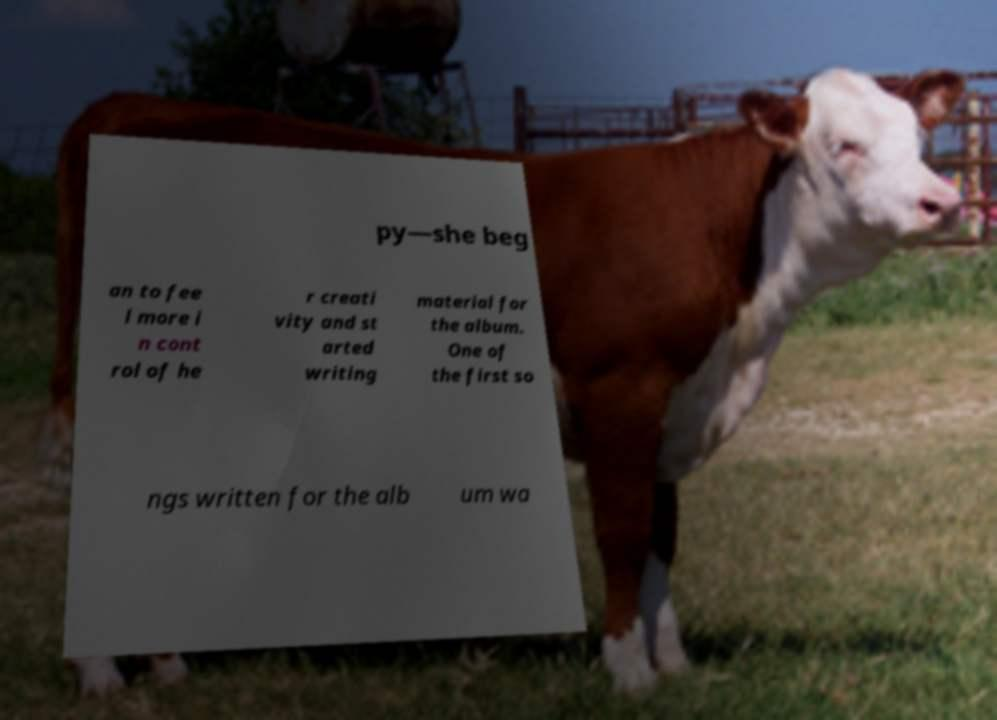Please read and relay the text visible in this image. What does it say? py—she beg an to fee l more i n cont rol of he r creati vity and st arted writing material for the album. One of the first so ngs written for the alb um wa 